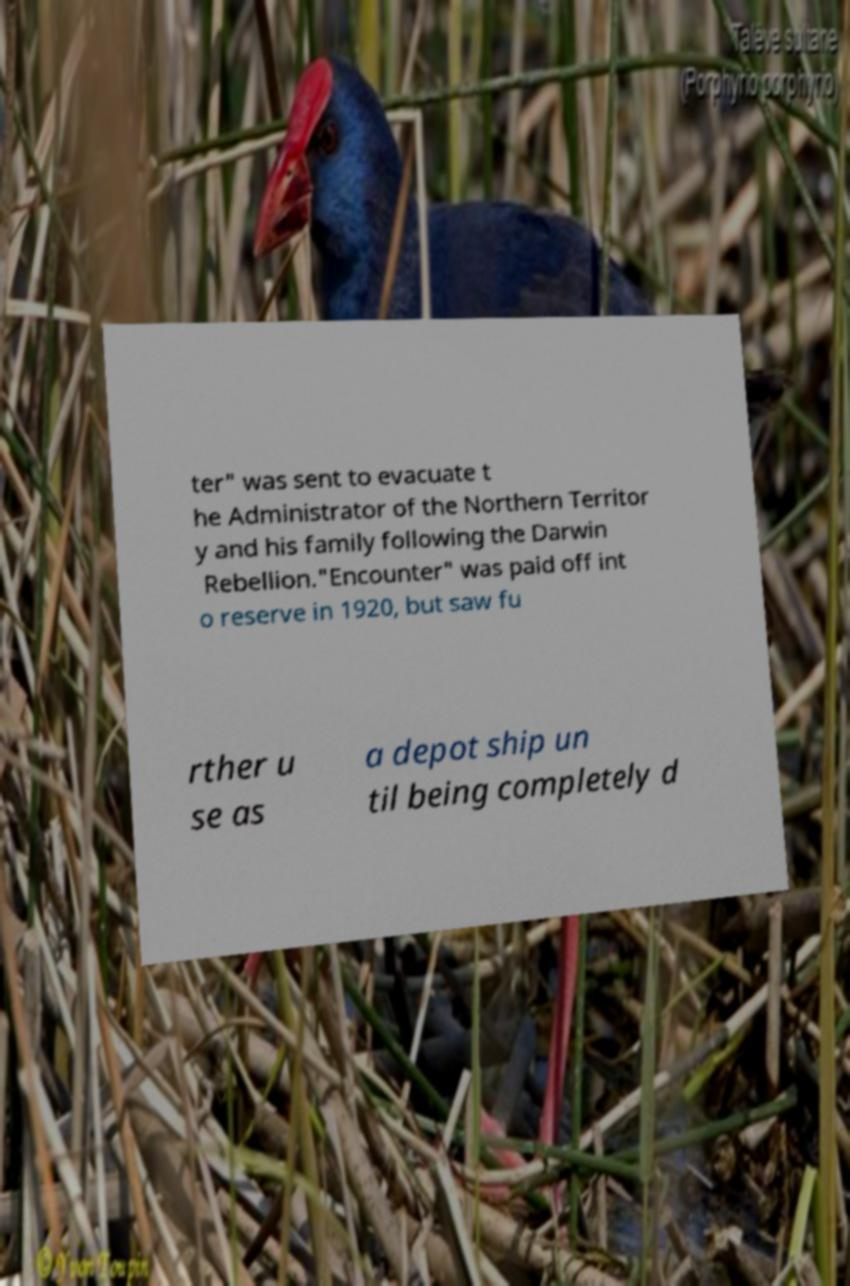Can you accurately transcribe the text from the provided image for me? ter" was sent to evacuate t he Administrator of the Northern Territor y and his family following the Darwin Rebellion."Encounter" was paid off int o reserve in 1920, but saw fu rther u se as a depot ship un til being completely d 